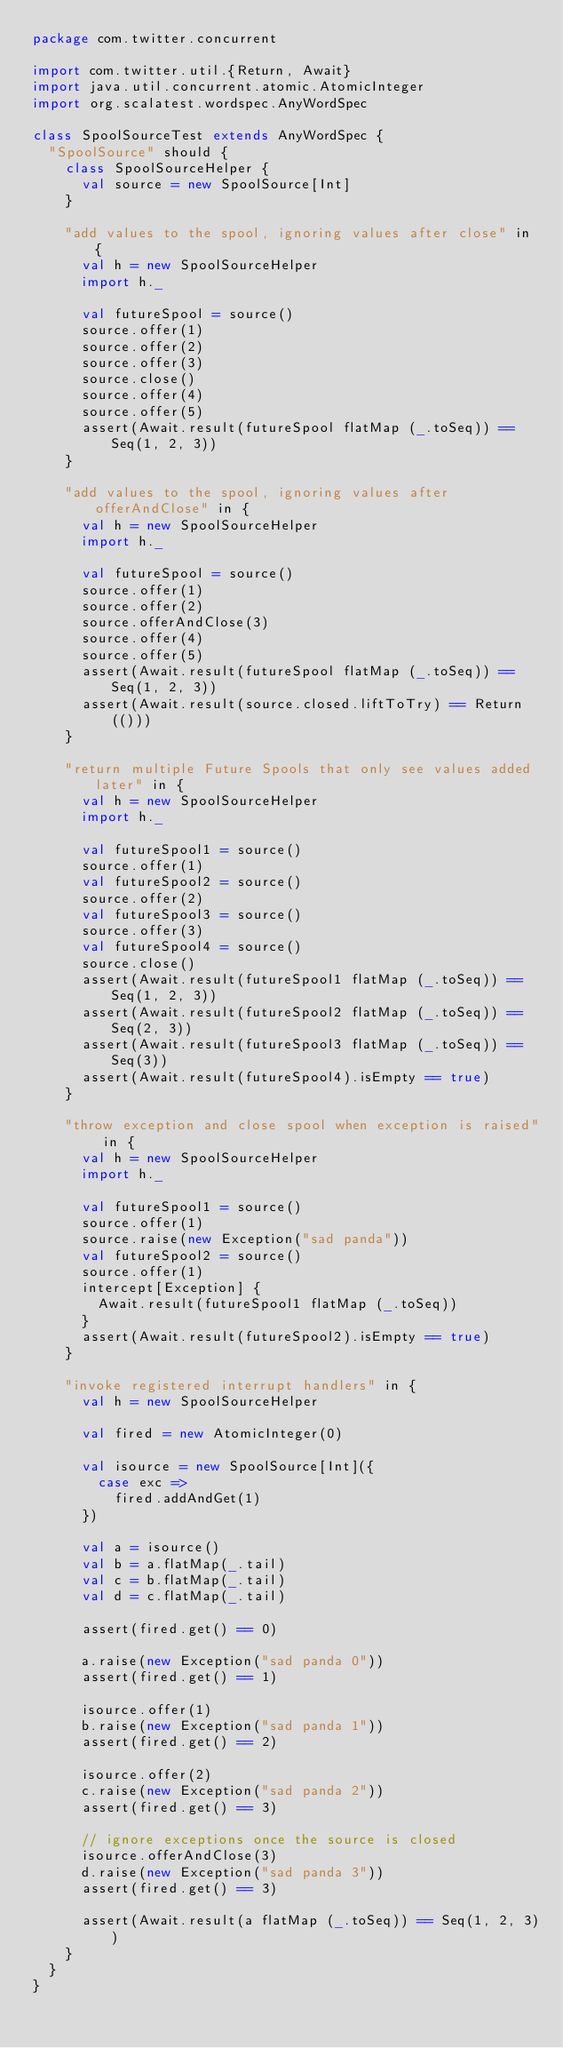Convert code to text. <code><loc_0><loc_0><loc_500><loc_500><_Scala_>package com.twitter.concurrent

import com.twitter.util.{Return, Await}
import java.util.concurrent.atomic.AtomicInteger
import org.scalatest.wordspec.AnyWordSpec

class SpoolSourceTest extends AnyWordSpec {
  "SpoolSource" should {
    class SpoolSourceHelper {
      val source = new SpoolSource[Int]
    }

    "add values to the spool, ignoring values after close" in {
      val h = new SpoolSourceHelper
      import h._

      val futureSpool = source()
      source.offer(1)
      source.offer(2)
      source.offer(3)
      source.close()
      source.offer(4)
      source.offer(5)
      assert(Await.result(futureSpool flatMap (_.toSeq)) == Seq(1, 2, 3))
    }

    "add values to the spool, ignoring values after offerAndClose" in {
      val h = new SpoolSourceHelper
      import h._

      val futureSpool = source()
      source.offer(1)
      source.offer(2)
      source.offerAndClose(3)
      source.offer(4)
      source.offer(5)
      assert(Await.result(futureSpool flatMap (_.toSeq)) == Seq(1, 2, 3))
      assert(Await.result(source.closed.liftToTry) == Return(()))
    }

    "return multiple Future Spools that only see values added later" in {
      val h = new SpoolSourceHelper
      import h._

      val futureSpool1 = source()
      source.offer(1)
      val futureSpool2 = source()
      source.offer(2)
      val futureSpool3 = source()
      source.offer(3)
      val futureSpool4 = source()
      source.close()
      assert(Await.result(futureSpool1 flatMap (_.toSeq)) == Seq(1, 2, 3))
      assert(Await.result(futureSpool2 flatMap (_.toSeq)) == Seq(2, 3))
      assert(Await.result(futureSpool3 flatMap (_.toSeq)) == Seq(3))
      assert(Await.result(futureSpool4).isEmpty == true)
    }

    "throw exception and close spool when exception is raised" in {
      val h = new SpoolSourceHelper
      import h._

      val futureSpool1 = source()
      source.offer(1)
      source.raise(new Exception("sad panda"))
      val futureSpool2 = source()
      source.offer(1)
      intercept[Exception] {
        Await.result(futureSpool1 flatMap (_.toSeq))
      }
      assert(Await.result(futureSpool2).isEmpty == true)
    }

    "invoke registered interrupt handlers" in {
      val h = new SpoolSourceHelper

      val fired = new AtomicInteger(0)

      val isource = new SpoolSource[Int]({
        case exc =>
          fired.addAndGet(1)
      })

      val a = isource()
      val b = a.flatMap(_.tail)
      val c = b.flatMap(_.tail)
      val d = c.flatMap(_.tail)

      assert(fired.get() == 0)

      a.raise(new Exception("sad panda 0"))
      assert(fired.get() == 1)

      isource.offer(1)
      b.raise(new Exception("sad panda 1"))
      assert(fired.get() == 2)

      isource.offer(2)
      c.raise(new Exception("sad panda 2"))
      assert(fired.get() == 3)

      // ignore exceptions once the source is closed
      isource.offerAndClose(3)
      d.raise(new Exception("sad panda 3"))
      assert(fired.get() == 3)

      assert(Await.result(a flatMap (_.toSeq)) == Seq(1, 2, 3))
    }
  }
}
</code> 